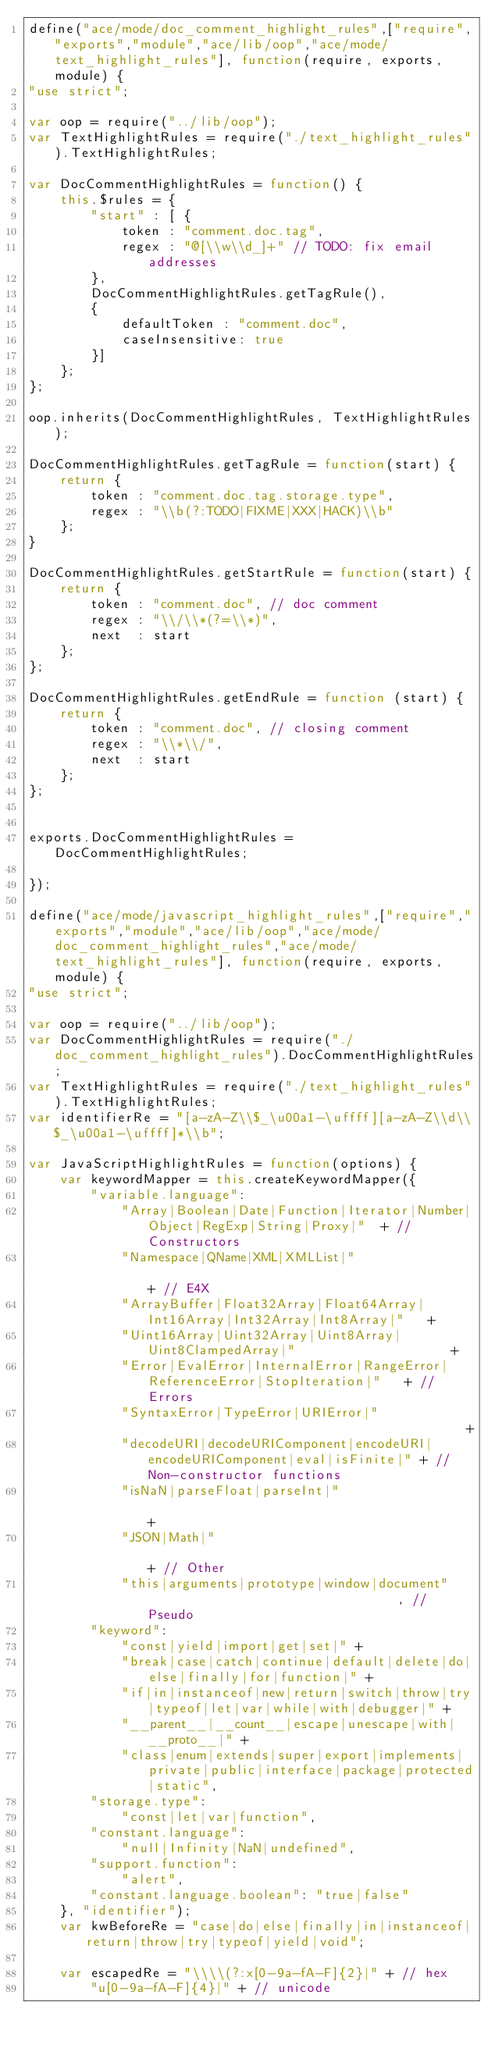<code> <loc_0><loc_0><loc_500><loc_500><_JavaScript_>define("ace/mode/doc_comment_highlight_rules",["require","exports","module","ace/lib/oop","ace/mode/text_highlight_rules"], function(require, exports, module) {
"use strict";

var oop = require("../lib/oop");
var TextHighlightRules = require("./text_highlight_rules").TextHighlightRules;

var DocCommentHighlightRules = function() {
    this.$rules = {
        "start" : [ {
            token : "comment.doc.tag",
            regex : "@[\\w\\d_]+" // TODO: fix email addresses
        }, 
        DocCommentHighlightRules.getTagRule(),
        {
            defaultToken : "comment.doc",
            caseInsensitive: true
        }]
    };
};

oop.inherits(DocCommentHighlightRules, TextHighlightRules);

DocCommentHighlightRules.getTagRule = function(start) {
    return {
        token : "comment.doc.tag.storage.type",
        regex : "\\b(?:TODO|FIXME|XXX|HACK)\\b"
    };
}

DocCommentHighlightRules.getStartRule = function(start) {
    return {
        token : "comment.doc", // doc comment
        regex : "\\/\\*(?=\\*)",
        next  : start
    };
};

DocCommentHighlightRules.getEndRule = function (start) {
    return {
        token : "comment.doc", // closing comment
        regex : "\\*\\/",
        next  : start
    };
};


exports.DocCommentHighlightRules = DocCommentHighlightRules;

});

define("ace/mode/javascript_highlight_rules",["require","exports","module","ace/lib/oop","ace/mode/doc_comment_highlight_rules","ace/mode/text_highlight_rules"], function(require, exports, module) {
"use strict";

var oop = require("../lib/oop");
var DocCommentHighlightRules = require("./doc_comment_highlight_rules").DocCommentHighlightRules;
var TextHighlightRules = require("./text_highlight_rules").TextHighlightRules;
var identifierRe = "[a-zA-Z\\$_\u00a1-\uffff][a-zA-Z\\d\\$_\u00a1-\uffff]*\\b";

var JavaScriptHighlightRules = function(options) {
    var keywordMapper = this.createKeywordMapper({
        "variable.language":
            "Array|Boolean|Date|Function|Iterator|Number|Object|RegExp|String|Proxy|"  + // Constructors
            "Namespace|QName|XML|XMLList|"                                             + // E4X
            "ArrayBuffer|Float32Array|Float64Array|Int16Array|Int32Array|Int8Array|"   +
            "Uint16Array|Uint32Array|Uint8Array|Uint8ClampedArray|"                    +
            "Error|EvalError|InternalError|RangeError|ReferenceError|StopIteration|"   + // Errors
            "SyntaxError|TypeError|URIError|"                                          +
            "decodeURI|decodeURIComponent|encodeURI|encodeURIComponent|eval|isFinite|" + // Non-constructor functions
            "isNaN|parseFloat|parseInt|"                                               +
            "JSON|Math|"                                                               + // Other
            "this|arguments|prototype|window|document"                                 , // Pseudo
        "keyword":
            "const|yield|import|get|set|" +
            "break|case|catch|continue|default|delete|do|else|finally|for|function|" +
            "if|in|instanceof|new|return|switch|throw|try|typeof|let|var|while|with|debugger|" +
            "__parent__|__count__|escape|unescape|with|__proto__|" +
            "class|enum|extends|super|export|implements|private|public|interface|package|protected|static",
        "storage.type":
            "const|let|var|function",
        "constant.language":
            "null|Infinity|NaN|undefined",
        "support.function":
            "alert",
        "constant.language.boolean": "true|false"
    }, "identifier");
    var kwBeforeRe = "case|do|else|finally|in|instanceof|return|throw|try|typeof|yield|void";

    var escapedRe = "\\\\(?:x[0-9a-fA-F]{2}|" + // hex
        "u[0-9a-fA-F]{4}|" + // unicode</code> 